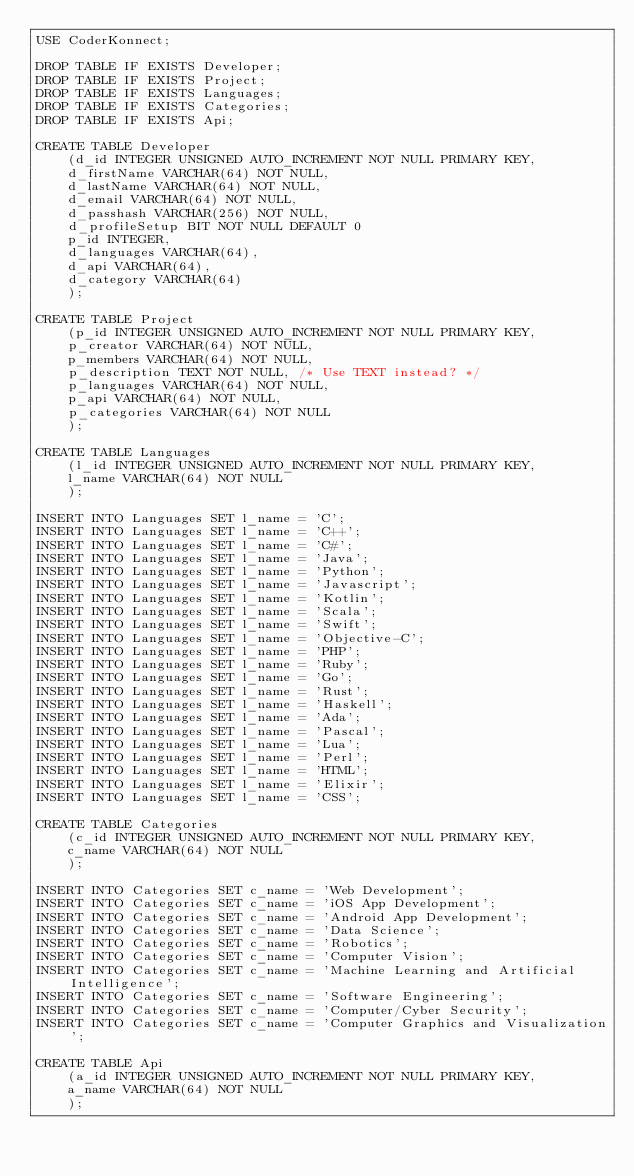Convert code to text. <code><loc_0><loc_0><loc_500><loc_500><_SQL_>USE CoderKonnect;

DROP TABLE IF EXISTS Developer;
DROP TABLE IF EXISTS Project;
DROP TABLE IF EXISTS Languages;
DROP TABLE IF EXISTS Categories;
DROP TABLE IF EXISTS Api;

CREATE TABLE Developer
	(d_id INTEGER UNSIGNED AUTO_INCREMENT NOT NULL PRIMARY KEY,
	d_firstName VARCHAR(64) NOT NULL,
	d_lastName VARCHAR(64) NOT NULL,
	d_email VARCHAR(64) NOT NULL,
	d_passhash VARCHAR(256) NOT NULL,
	d_profileSetup BIT NOT NULL DEFAULT 0
	p_id INTEGER,
	d_languages VARCHAR(64),
	d_api VARCHAR(64),
	d_category VARCHAR(64)
	);

CREATE TABLE Project
	(p_id INTEGER UNSIGNED AUTO_INCREMENT NOT NULL PRIMARY KEY,
	p_creator VARCHAR(64) NOT NULL,
	p_members VARCHAR(64) NOT NULL,
	p_description TEXT NOT NULL, /* Use TEXT instead? */
	p_languages VARCHAR(64) NOT NULL,
	p_api VARCHAR(64) NOT NULL,
	p_categories VARCHAR(64) NOT NULL
	);

CREATE TABLE Languages
	(l_id INTEGER UNSIGNED AUTO_INCREMENT NOT NULL PRIMARY KEY,
	l_name VARCHAR(64) NOT NULL
	);

INSERT INTO Languages SET l_name = 'C';
INSERT INTO Languages SET l_name = 'C++';
INSERT INTO Languages SET l_name = 'C#';
INSERT INTO Languages SET l_name = 'Java';
INSERT INTO Languages SET l_name = 'Python';
INSERT INTO Languages SET l_name = 'Javascript';
INSERT INTO Languages SET l_name = 'Kotlin';
INSERT INTO Languages SET l_name = 'Scala';
INSERT INTO Languages SET l_name = 'Swift';
INSERT INTO Languages SET l_name = 'Objective-C';
INSERT INTO Languages SET l_name = 'PHP';
INSERT INTO Languages SET l_name = 'Ruby';
INSERT INTO Languages SET l_name = 'Go';
INSERT INTO Languages SET l_name = 'Rust';
INSERT INTO Languages SET l_name = 'Haskell';
INSERT INTO Languages SET l_name = 'Ada';
INSERT INTO Languages SET l_name = 'Pascal';
INSERT INTO Languages SET l_name = 'Lua';
INSERT INTO Languages SET l_name = 'Perl';
INSERT INTO Languages SET l_name = 'HTML';
INSERT INTO Languages SET l_name = 'Elixir';
INSERT INTO Languages SET l_name = 'CSS';
	
CREATE TABLE Categories
	(c_id INTEGER UNSIGNED AUTO_INCREMENT NOT NULL PRIMARY KEY,
	c_name VARCHAR(64) NOT NULL
	);

INSERT INTO Categories SET c_name = 'Web Development';
INSERT INTO Categories SET c_name = 'iOS App Development';
INSERT INTO Categories SET c_name = 'Android App Development';
INSERT INTO Categories SET c_name = 'Data Science';
INSERT INTO Categories SET c_name = 'Robotics';
INSERT INTO Categories SET c_name = 'Computer Vision';
INSERT INTO Categories SET c_name = 'Machine Learning and Artificial Intelligence';
INSERT INTO Categories SET c_name = 'Software Engineering';
INSERT INTO Categories SET c_name = 'Computer/Cyber Security';
INSERT INTO Categories SET c_name = 'Computer Graphics and Visualization';
	
CREATE TABLE Api
	(a_id INTEGER UNSIGNED AUTO_INCREMENT NOT NULL PRIMARY KEY,
	a_name VARCHAR(64) NOT NULL
	);
</code> 